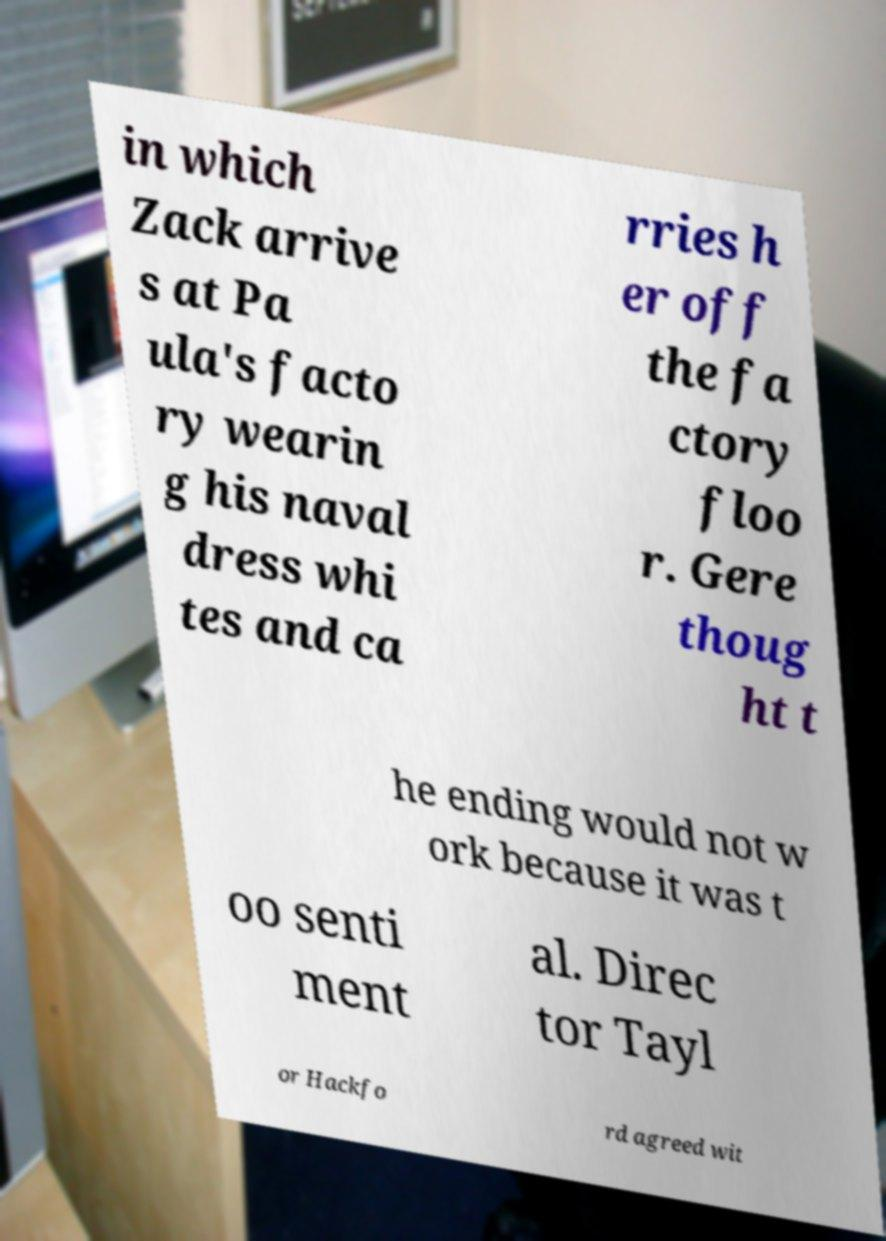Could you extract and type out the text from this image? in which Zack arrive s at Pa ula's facto ry wearin g his naval dress whi tes and ca rries h er off the fa ctory floo r. Gere thoug ht t he ending would not w ork because it was t oo senti ment al. Direc tor Tayl or Hackfo rd agreed wit 